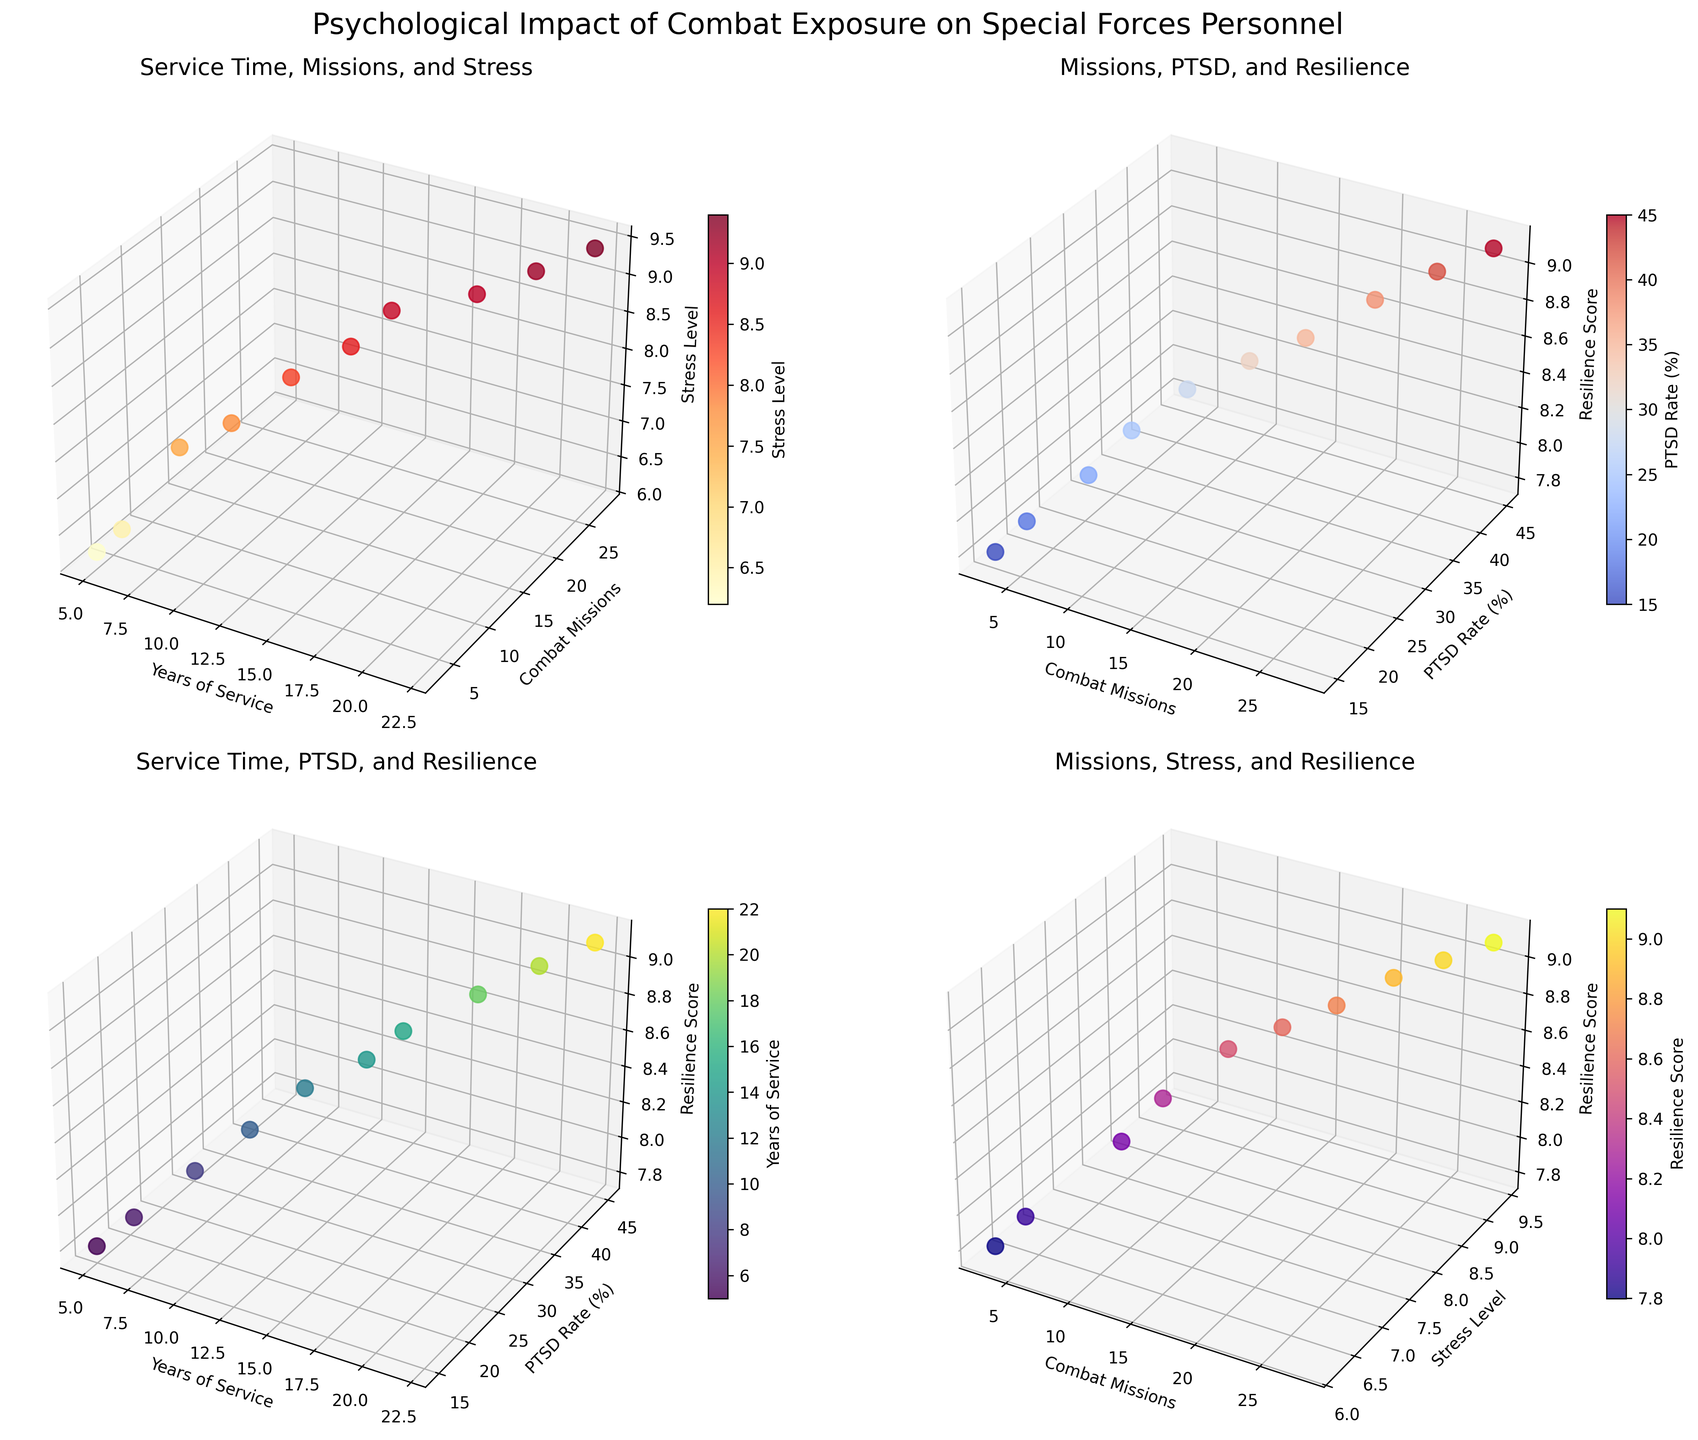What is the title of the figure? The title of the figure is located at the top center of the chart, summarizing the overall theme of the data visualizations. It reads "Psychological Impact of Combat Exposure on Special Forces Personnel."
Answer: Psychological Impact of Combat Exposure on Special Forces Personnel What are the axes labels in the first subplot? The axes labels in the first subplot are found along the axes of the 3D plot. The x-axis label is "Years of Service," the y-axis label is "Combat Missions," and the z-axis label is "Stress Level."
Answer: Years of Service, Combat Missions, Stress Level How many data points are plotted in each subplot? To determine the number of data points, one should count the distinct points represented in each subplot. All subplots use the same dataset, indicating there are 10 data points plotted in each.
Answer: 10 What is the range of Stress Levels in the first subplot? The range of Stress Levels can be obtained by identifying the maximum and minimum values on the Stress Level axis in the first subplot. The range is the difference between these two values. The maximum is 9.4, and the minimum is 6.2, so the range is 9.4 - 6.2 = 3.2.
Answer: 3.2 What's the average Resilience Score of the data points with more than 15 Combat Missions in the second subplot? To find this, identify data points with more than 15 Combat Missions, then sum their Resilience Scores and divide by the number of these data points. The relevant points are the ones with 18, 22, and 28 Combat Missions having Resilience Scores of 8.7, 8.9, and 9.1 respectively. Their average Resilience Score is (8.7 + 8.9 + 9.1) / 3 = 8.9.
Answer: 8.9 Which data point has the highest Resilience Score in the second subplot? In the second subplot, the Resilience Score is one of the axes. By identifying which data point corresponds to the highest value on the Resilience Score axis, the data point with a score of 9.1 (associated with DEVGRU) is identified.
Answer: DEVGRU Compare the PTSD Rate of data points with 10 and 20 Years of Service in the third subplot. Which is higher? Locate the data points with 10 and 20 Years of Service on the PTSD Rate axis in the third subplot. The PTSD Rates are 25 and 42 respectively, indicating that the PTSD Rate is higher for those with 20 Years of Service.
Answer: 20 Years of Service In the fourth subplot, is there a trend between Combat Missions and Stress Level? Analyzing the distribution of points in the fourth subplot, one can determine if there is a general increasing or decreasing pattern. There appears to be a trend where Stress Level increases with Combat Missions, indicating a positive relationship.
Answer: Yes, increasing According to the first subplot, which unit appears to have the highest Stress Level and what are its Years of Service and Combat Missions? Find the point with the highest Stress Level in the first subplot, which corresponds to 9.4. This is associated with DEVGRU. They have 22 Years of Service and 28 Combat Missions.
Answer: DEVGRU: 22 Years of Service, 28 Combat Missions 